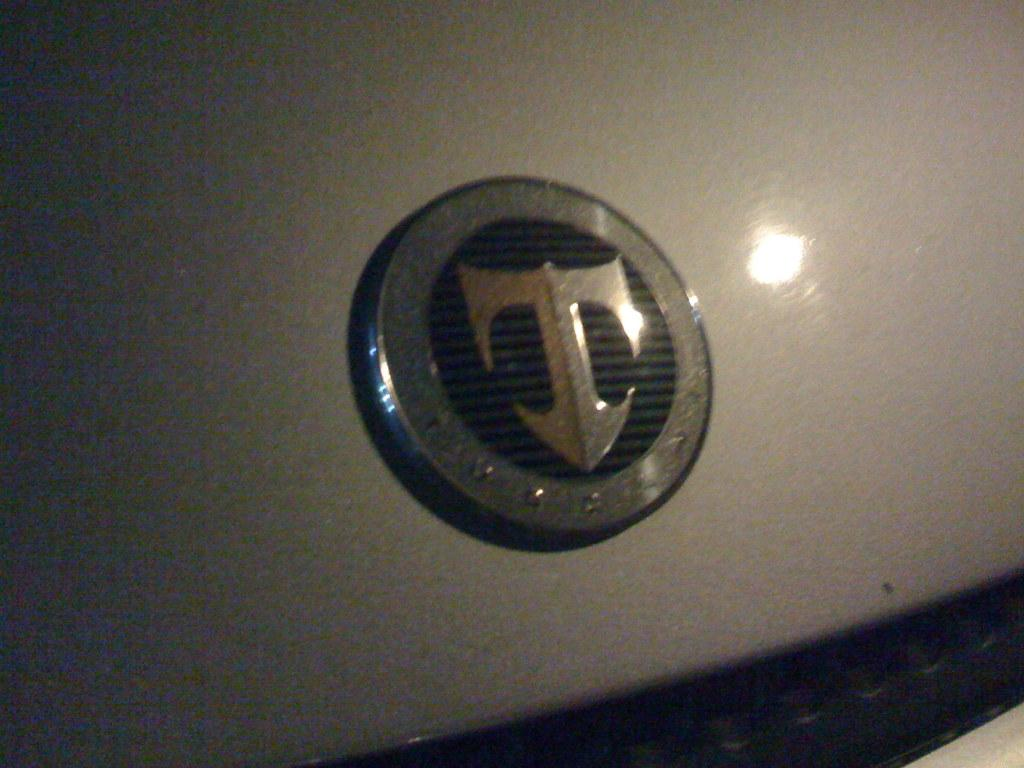What is located on the bonnet of the vehicle in the image? There is an emblem on the bonnet of the vehicle in the image. How does the emblem on the bonnet of the vehicle in the image create friction? The emblem on the bonnet of the vehicle in the image does not create friction, as it is a stationary object and friction is a force that occurs between moving objects. 